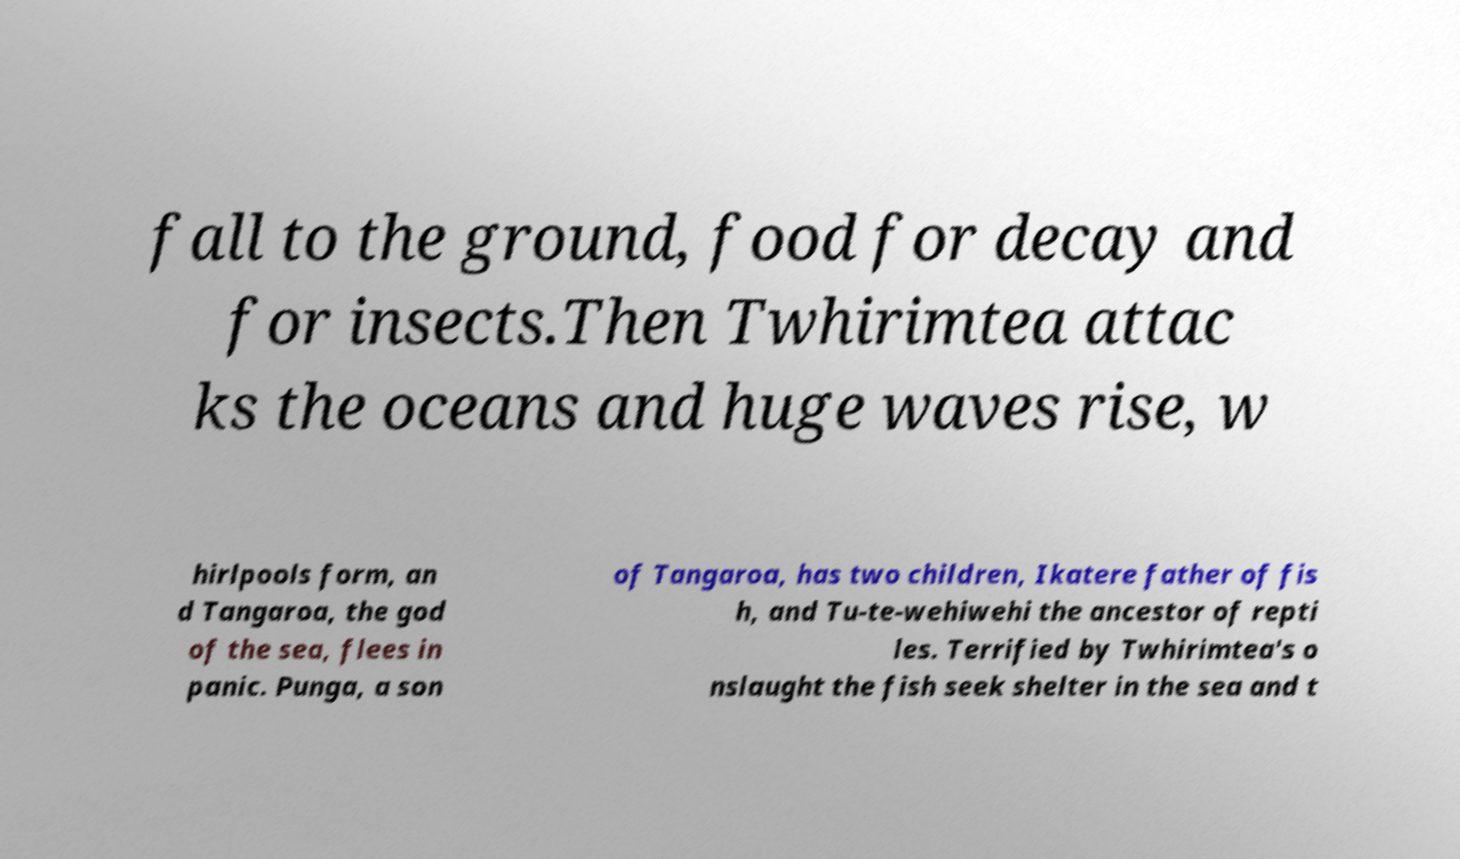Please read and relay the text visible in this image. What does it say? fall to the ground, food for decay and for insects.Then Twhirimtea attac ks the oceans and huge waves rise, w hirlpools form, an d Tangaroa, the god of the sea, flees in panic. Punga, a son of Tangaroa, has two children, Ikatere father of fis h, and Tu-te-wehiwehi the ancestor of repti les. Terrified by Twhirimtea's o nslaught the fish seek shelter in the sea and t 